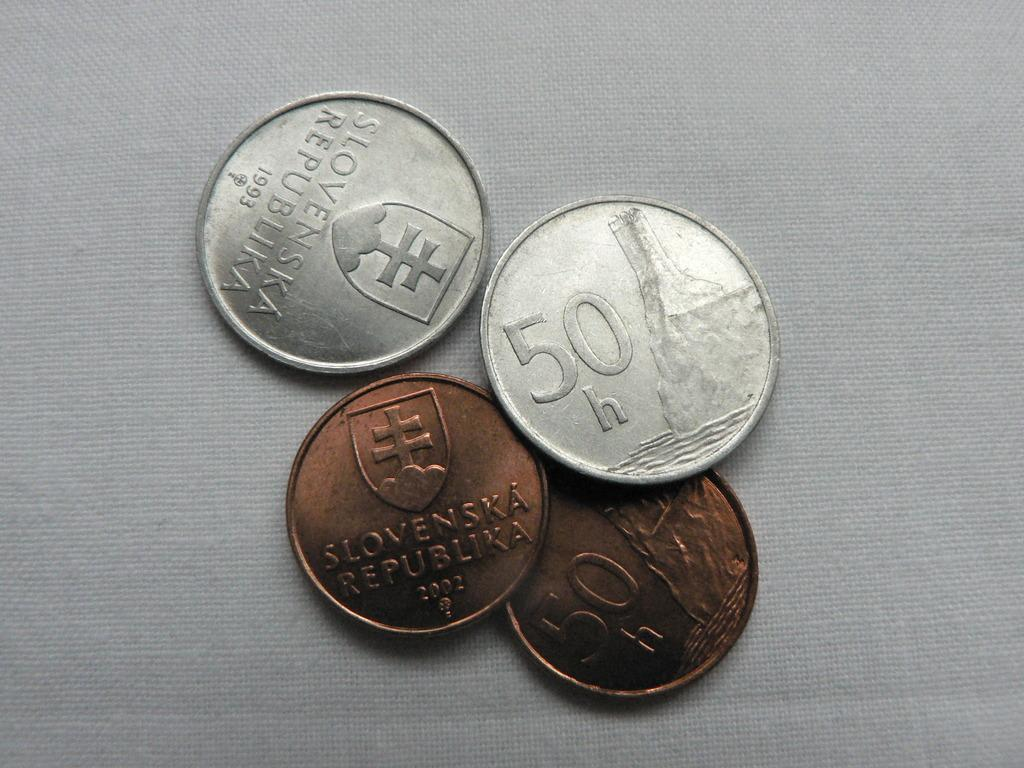Provide a one-sentence caption for the provided image. A grouping of four coins with the denomination 50 on two of them. 